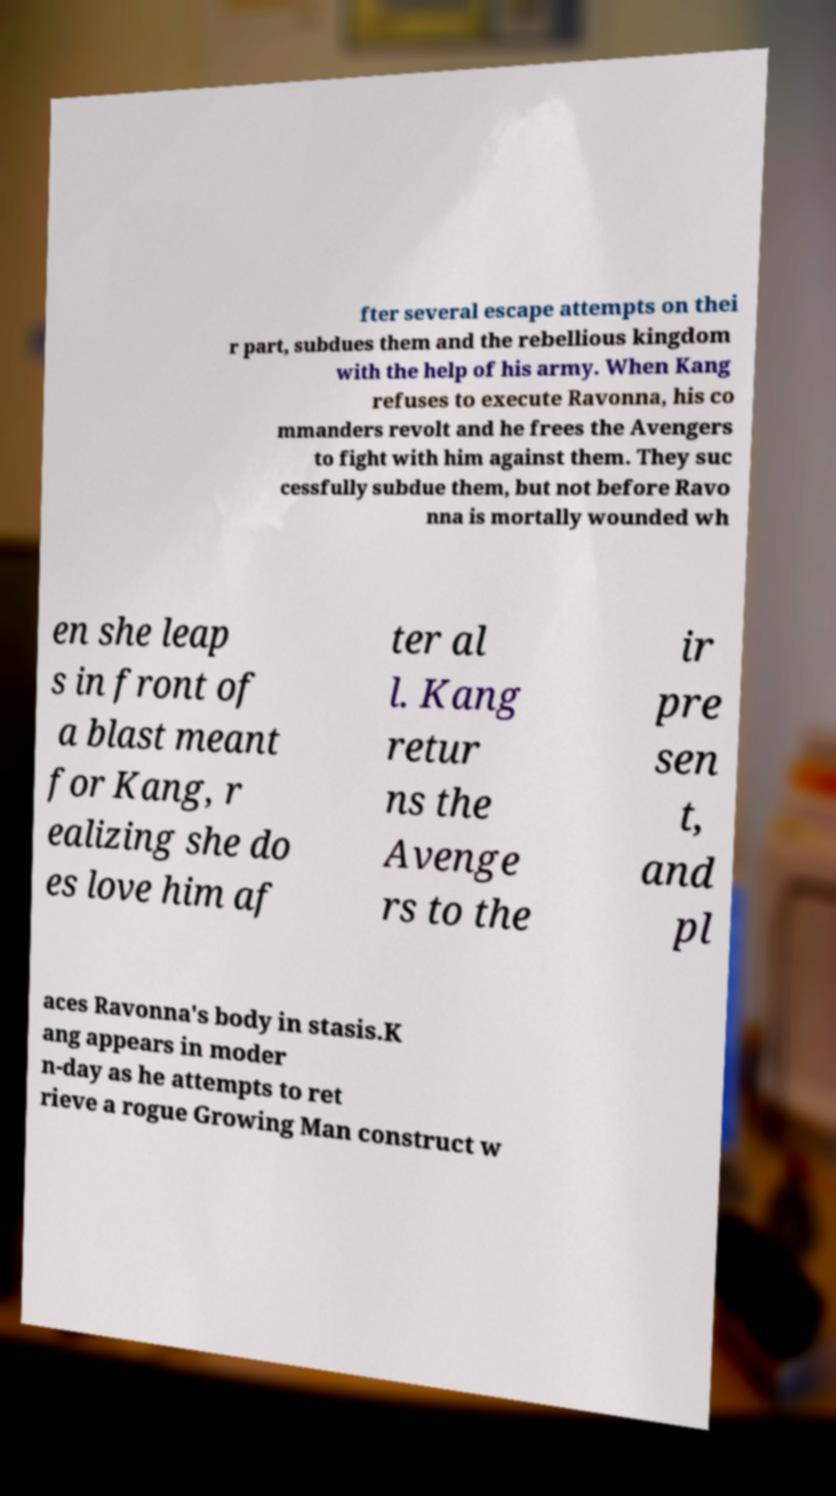Please read and relay the text visible in this image. What does it say? fter several escape attempts on thei r part, subdues them and the rebellious kingdom with the help of his army. When Kang refuses to execute Ravonna, his co mmanders revolt and he frees the Avengers to fight with him against them. They suc cessfully subdue them, but not before Ravo nna is mortally wounded wh en she leap s in front of a blast meant for Kang, r ealizing she do es love him af ter al l. Kang retur ns the Avenge rs to the ir pre sen t, and pl aces Ravonna's body in stasis.K ang appears in moder n-day as he attempts to ret rieve a rogue Growing Man construct w 